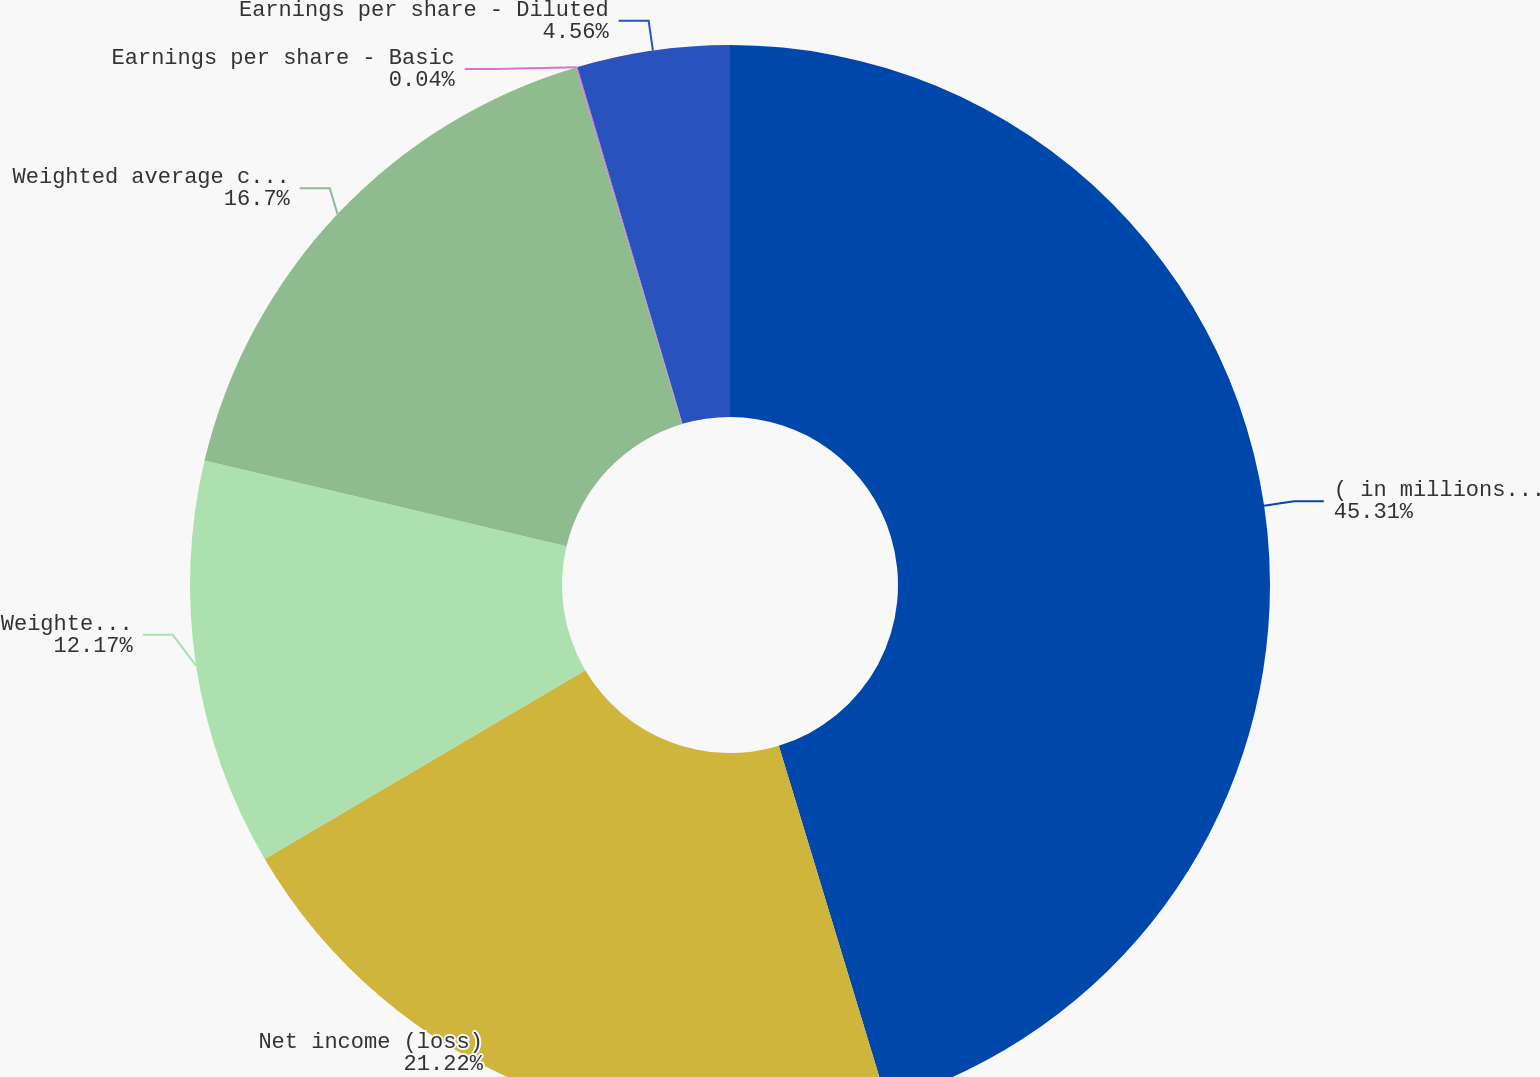<chart> <loc_0><loc_0><loc_500><loc_500><pie_chart><fcel>( in millions except per share<fcel>Net income (loss)<fcel>Weighted average common shares<fcel>Weighted average common and<fcel>Earnings per share - Basic<fcel>Earnings per share - Diluted<nl><fcel>45.31%<fcel>21.22%<fcel>12.17%<fcel>16.7%<fcel>0.04%<fcel>4.56%<nl></chart> 